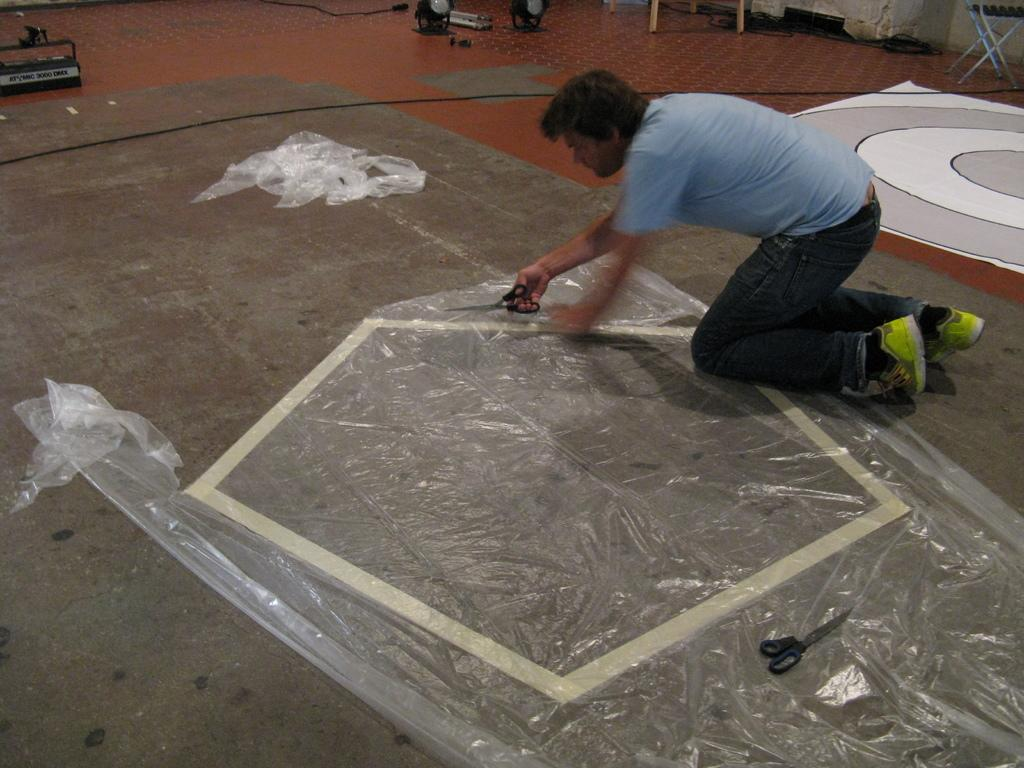What is the man in the image doing? The man is sitting and placing a cover on the floor. What object is the man holding in his hand? The man is holding a scissor in his hand. What can be seen in the background of the image? There is a wire, a table, a cloth, and another scissor in the background of the image. What type of riddle can be solved using the oranges and coal in the image? There are no oranges or coal present in the image, so it is not possible to solve a riddle using them. 